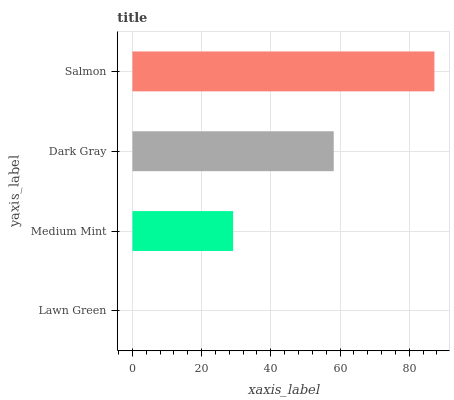Is Lawn Green the minimum?
Answer yes or no. Yes. Is Salmon the maximum?
Answer yes or no. Yes. Is Medium Mint the minimum?
Answer yes or no. No. Is Medium Mint the maximum?
Answer yes or no. No. Is Medium Mint greater than Lawn Green?
Answer yes or no. Yes. Is Lawn Green less than Medium Mint?
Answer yes or no. Yes. Is Lawn Green greater than Medium Mint?
Answer yes or no. No. Is Medium Mint less than Lawn Green?
Answer yes or no. No. Is Dark Gray the high median?
Answer yes or no. Yes. Is Medium Mint the low median?
Answer yes or no. Yes. Is Salmon the high median?
Answer yes or no. No. Is Salmon the low median?
Answer yes or no. No. 